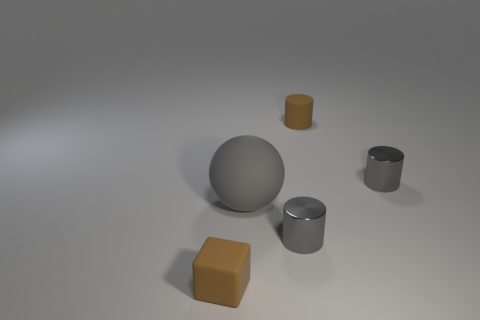Add 4 big red objects. How many objects exist? 9 Subtract all tiny brown cylinders. How many cylinders are left? 2 Subtract all purple cubes. How many gray cylinders are left? 2 Subtract all cubes. How many objects are left? 4 Subtract all brown cylinders. How many cylinders are left? 2 Add 5 tiny brown cylinders. How many tiny brown cylinders exist? 6 Subtract 0 red cylinders. How many objects are left? 5 Subtract all green cubes. Subtract all blue balls. How many cubes are left? 1 Subtract all cyan metallic things. Subtract all gray cylinders. How many objects are left? 3 Add 2 small brown matte blocks. How many small brown matte blocks are left? 3 